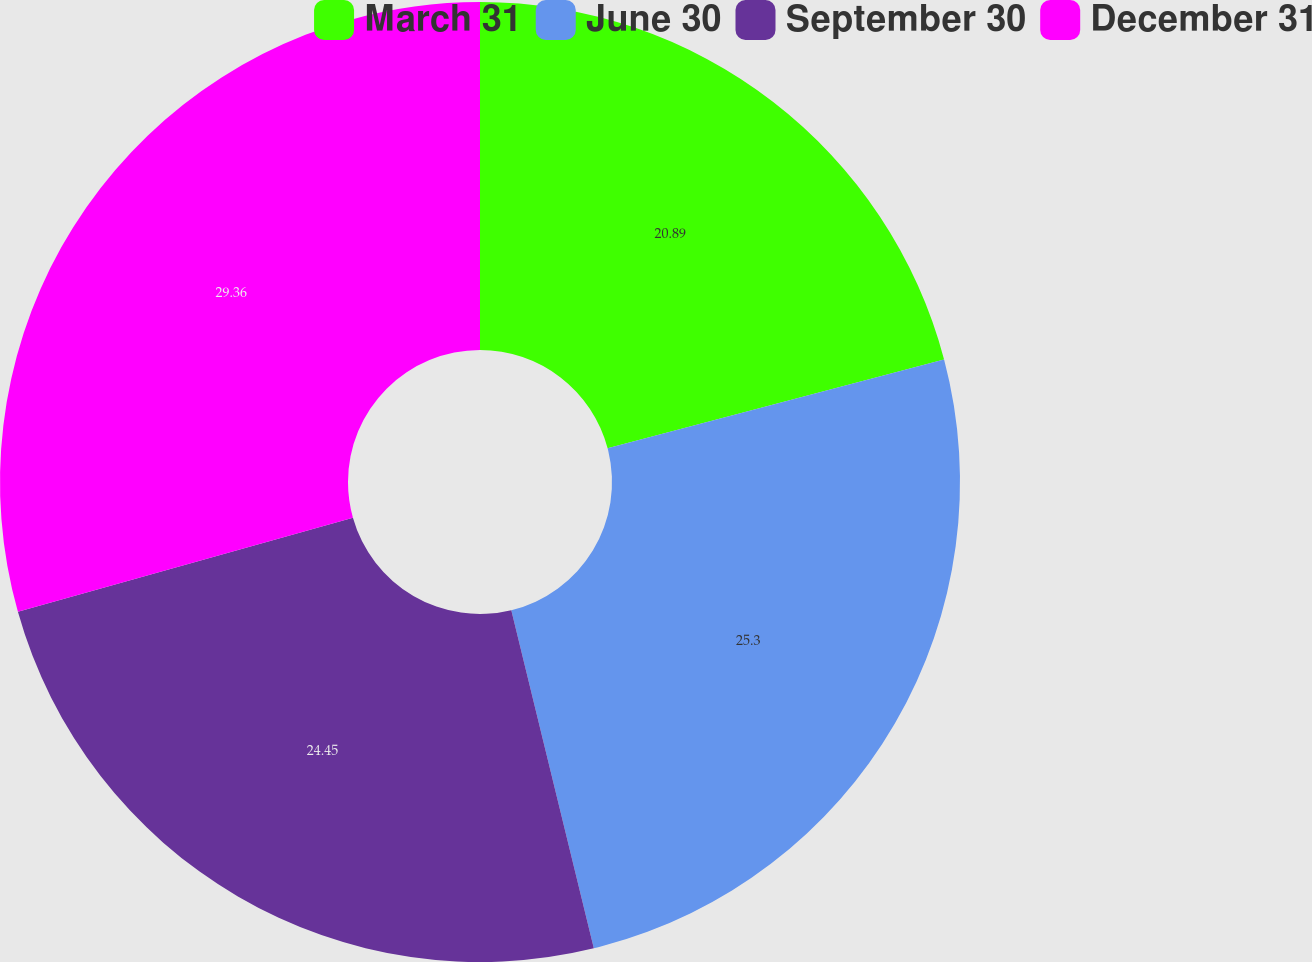Convert chart to OTSL. <chart><loc_0><loc_0><loc_500><loc_500><pie_chart><fcel>March 31<fcel>June 30<fcel>September 30<fcel>December 31<nl><fcel>20.89%<fcel>25.3%<fcel>24.45%<fcel>29.36%<nl></chart> 